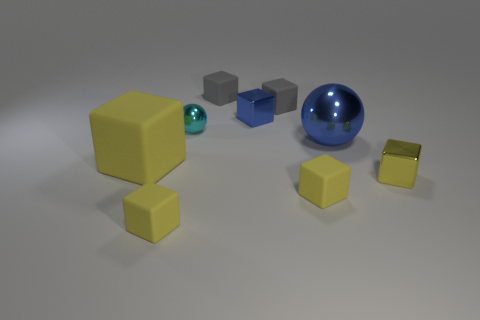Subtract all yellow cubes. How many were subtracted if there are2yellow cubes left? 2 Subtract all shiny cubes. How many cubes are left? 5 Subtract all blue cylinders. How many gray blocks are left? 2 Subtract all gray blocks. How many blocks are left? 5 Add 1 brown rubber cylinders. How many objects exist? 10 Subtract 2 cubes. How many cubes are left? 5 Subtract all cubes. How many objects are left? 2 Subtract all brown blocks. Subtract all purple cylinders. How many blocks are left? 7 Subtract all tiny cyan balls. Subtract all yellow objects. How many objects are left? 4 Add 1 small gray matte objects. How many small gray matte objects are left? 3 